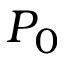<formula> <loc_0><loc_0><loc_500><loc_500>P _ { 0 }</formula> 